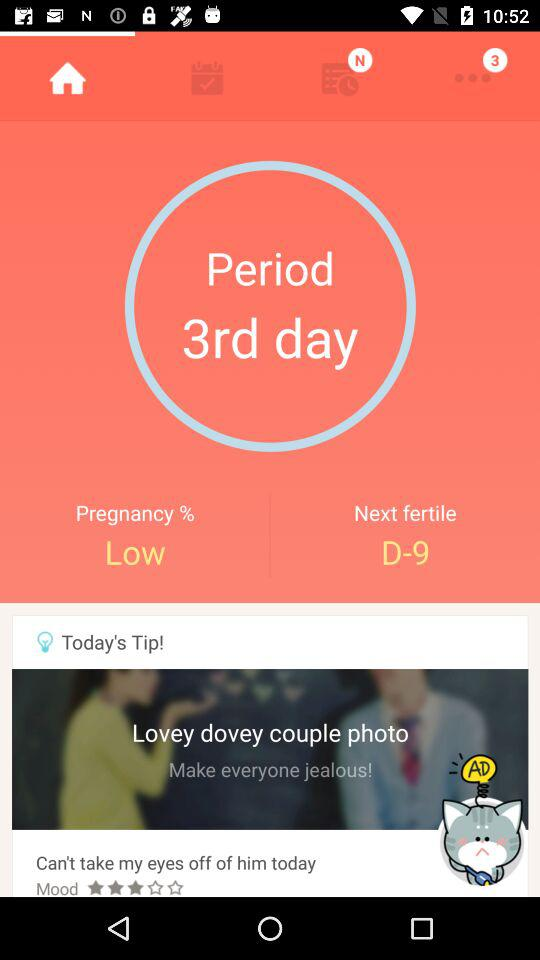What is the pregnancy percentage? The pregnancy percentage is low. 